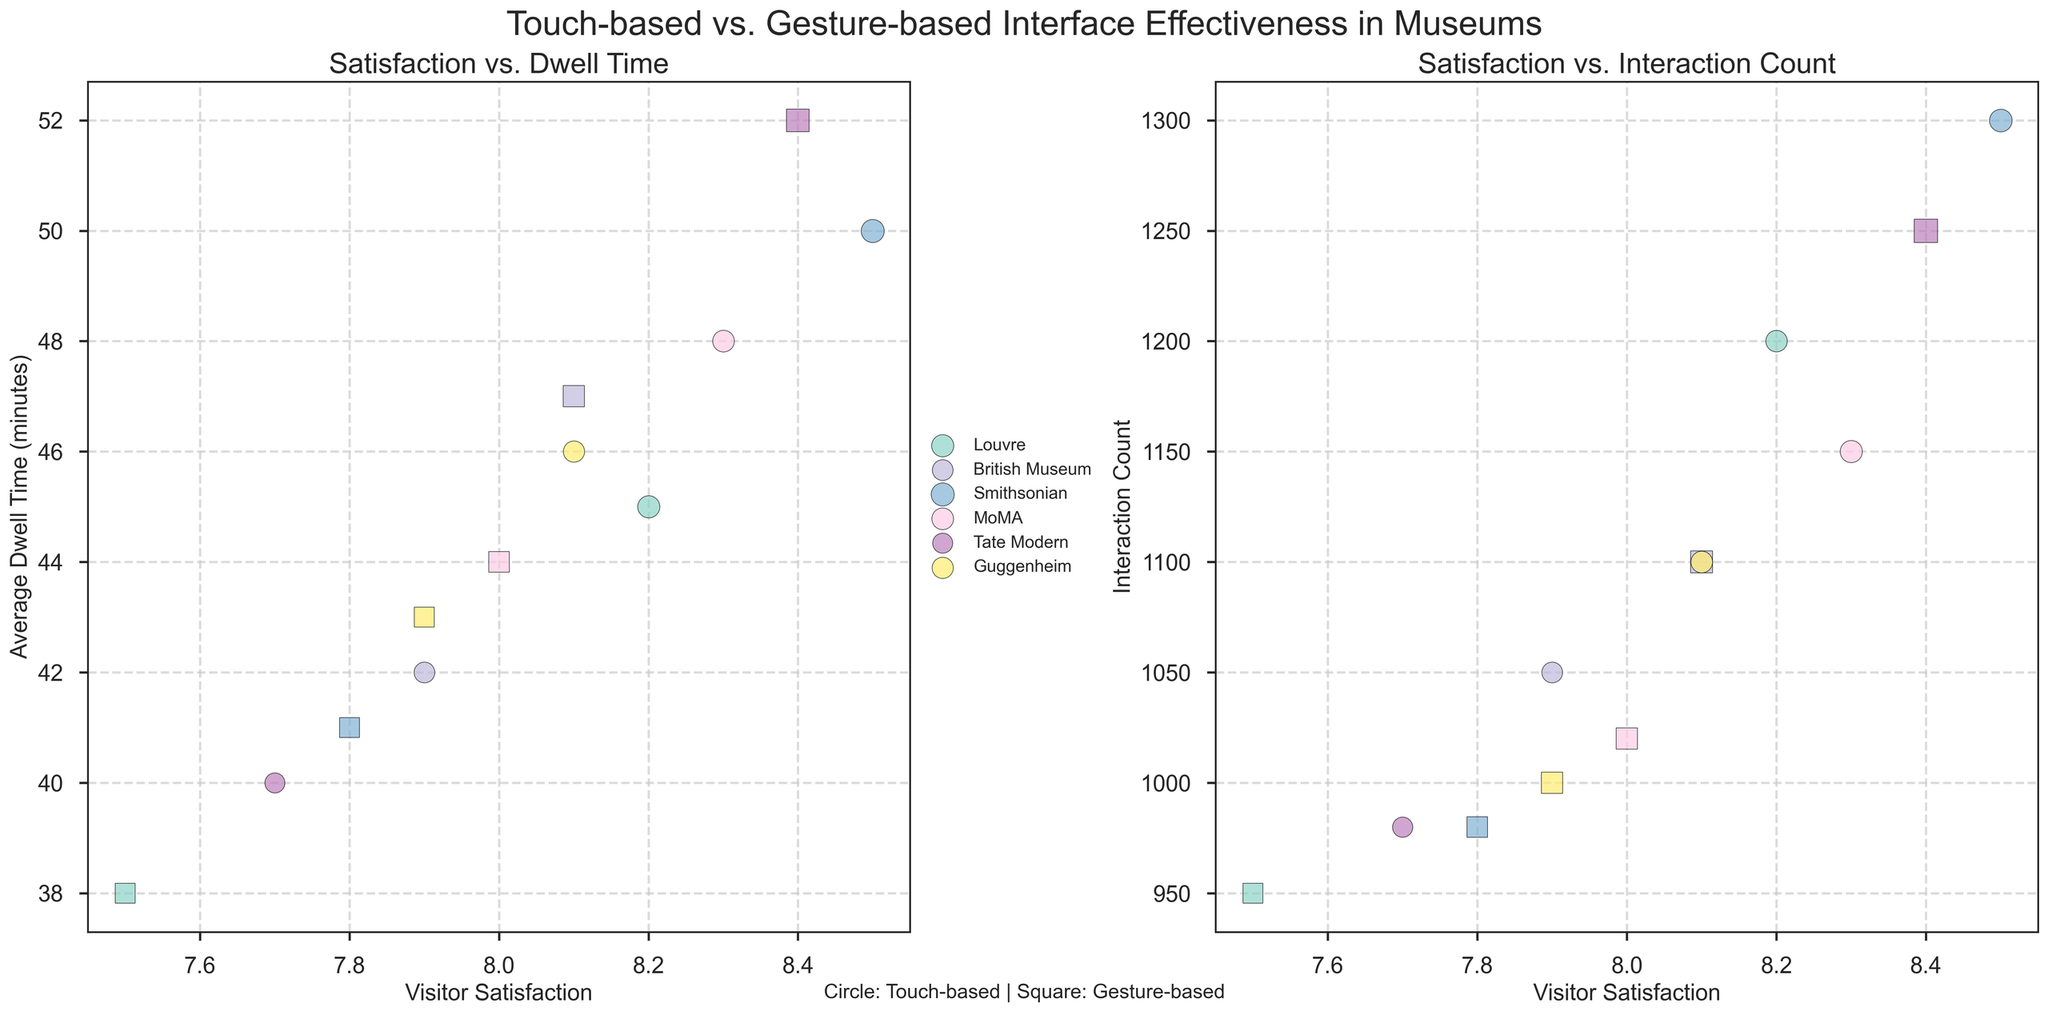What is the title of the figure? The title is typically found at the top of the figure and summarizes its content. It's intended to give viewers an immediate understanding of what the figure represents.
Answer: Touch-based vs. Gesture-based Interface Effectiveness in Museums What are the two subplots comparing? The figure is divided into two subplots that are designed to highlight different comparisons of the same data. The left subplot compares visitor satisfaction against average dwell time, while the right subplot compares visitor satisfaction against interaction count.
Answer: Visitor satisfaction vs. average dwell time, and visitor satisfaction vs. interaction count Which museum shows a higher average dwell time for gesture-based interfaces compared to touch-based interfaces? Looking at the left subplot, we can identify the different museums by their colors and focus on the gesture-based (square) and touch-based (circle) points. For each museum, we can compare the vertical positions of these two points.
Answer: Tate Modern Which museum has the highest visitor satisfaction for touch-based interfaces? By looking at the points in the left subplot that are circles (touch-based) and identifying the museum labels, we can determine which one is highest on the visitor satisfaction axis.
Answer: Smithsonian What is the average dwell time for touch-based interfaces at MoMA? Locate the point corresponding to MoMA's touch-based interface (circle) in the left subplot and check its vertical position along the average dwell time axis.
Answer: 48 minutes How does the interaction count for the British Museum’s touch-based interface compare to its gesture-based interface? In the right subplot, compare the vertical positions of the touch-based (circle) and gesture-based (square) points corresponding to the British Museum.
Answer: Lower for touch-based What is the difference in average dwell time between touch-based and gesture-based interfaces at the Guggenheim? Identify the vertical positions of the touch-based (circle) and gesture-based (square) points for the Guggenheim in the left subplot and calculate the difference.
Answer: 3 minutes Which interface type shows generally higher visitor satisfaction across all museums? By comparing the overall trend of the touch-based (circles) and gesture-based (squares) points in any one subplot, we can assess which interface type tends to have higher visitor satisfaction values.
Answer: Touch-based What are the colors used to distinguish different museums? The colors in the figure represent different museums. We can identify each museum by looking at the legend located at the left of the figure.
Answer: Various distinct colors from the Set3 colormap Which museum has both high visitor satisfaction and high interaction count for a gesture-based interface? In the right subplot, look for a square (gesture-based) with a high position on both the visitor satisfaction and interaction count axes.
Answer: British Museum Summarize how widely visitor satisfaction varies between touch-based and gesture-based interfaces at the Louvre. For the Louvre, compare the horizontal positions of its touch-based and gesture-based points in both subplots to see the spread in visitor satisfaction.
Answer: 0.7 units 